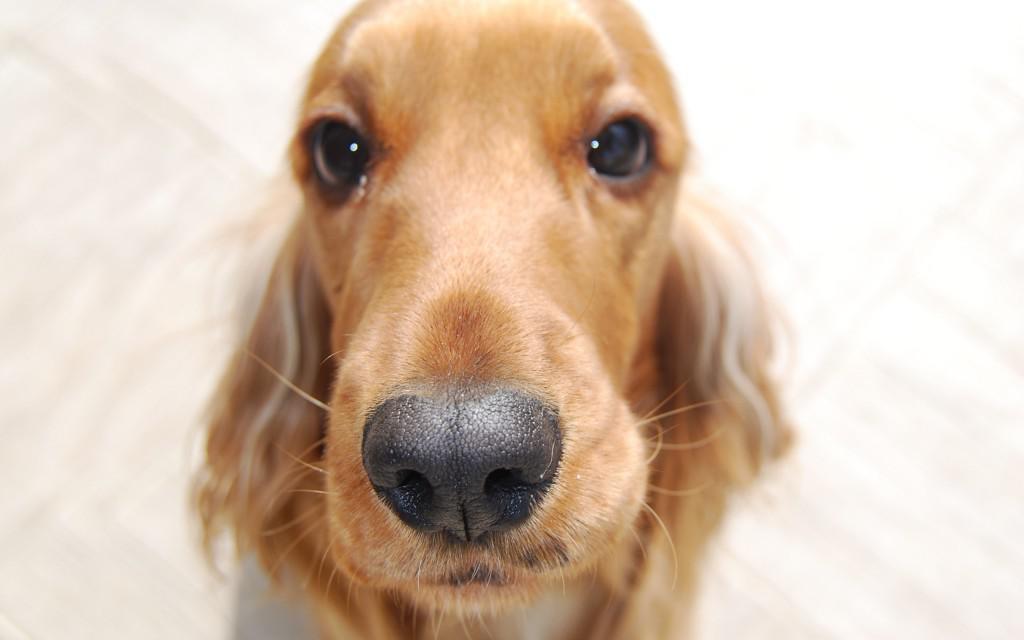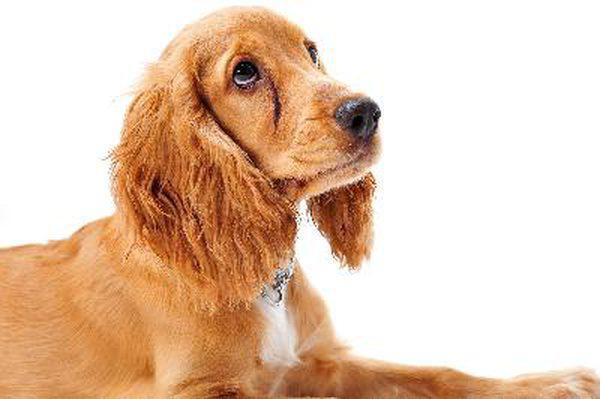The first image is the image on the left, the second image is the image on the right. For the images displayed, is the sentence "The tongue is out on one of the dog." factually correct? Answer yes or no. No. The first image is the image on the left, the second image is the image on the right. For the images shown, is this caption "An image shows a spaniel looking upward to the right." true? Answer yes or no. Yes. 